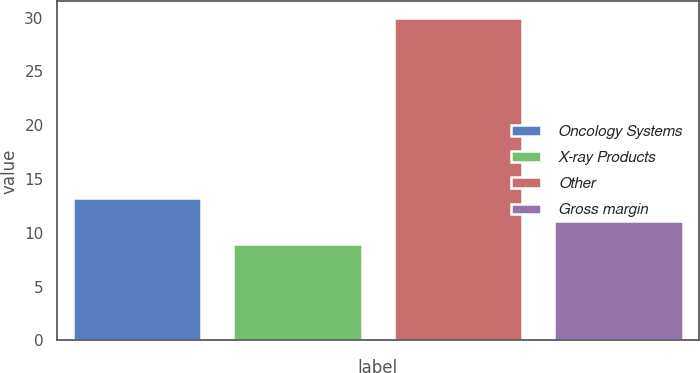Convert chart. <chart><loc_0><loc_0><loc_500><loc_500><bar_chart><fcel>Oncology Systems<fcel>X-ray Products<fcel>Other<fcel>Gross margin<nl><fcel>13.2<fcel>9<fcel>30<fcel>11.1<nl></chart> 